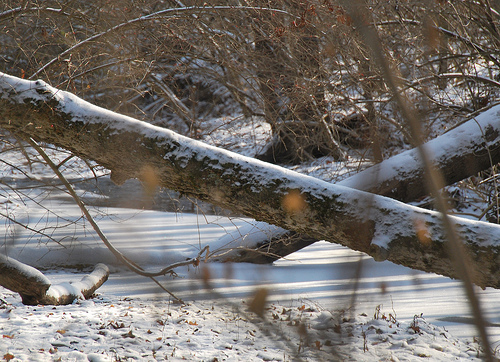<image>
Is the tree next to the river? No. The tree is not positioned next to the river. They are located in different areas of the scene. 